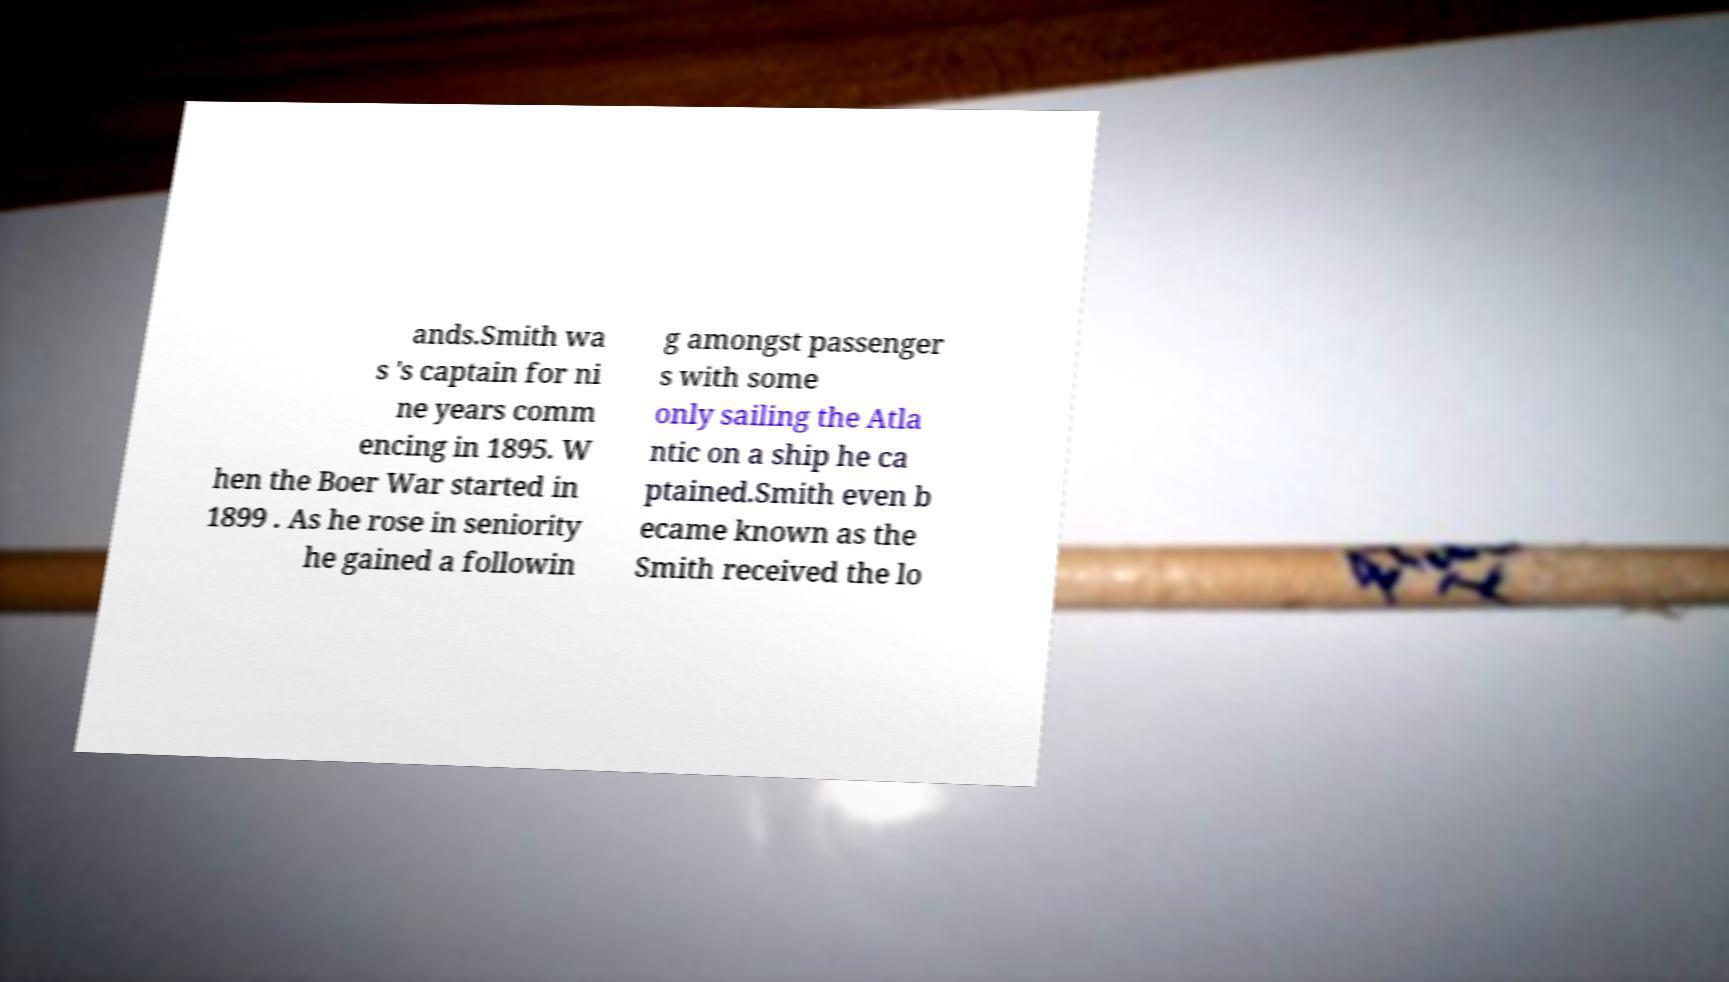There's text embedded in this image that I need extracted. Can you transcribe it verbatim? ands.Smith wa s 's captain for ni ne years comm encing in 1895. W hen the Boer War started in 1899 . As he rose in seniority he gained a followin g amongst passenger s with some only sailing the Atla ntic on a ship he ca ptained.Smith even b ecame known as the Smith received the lo 